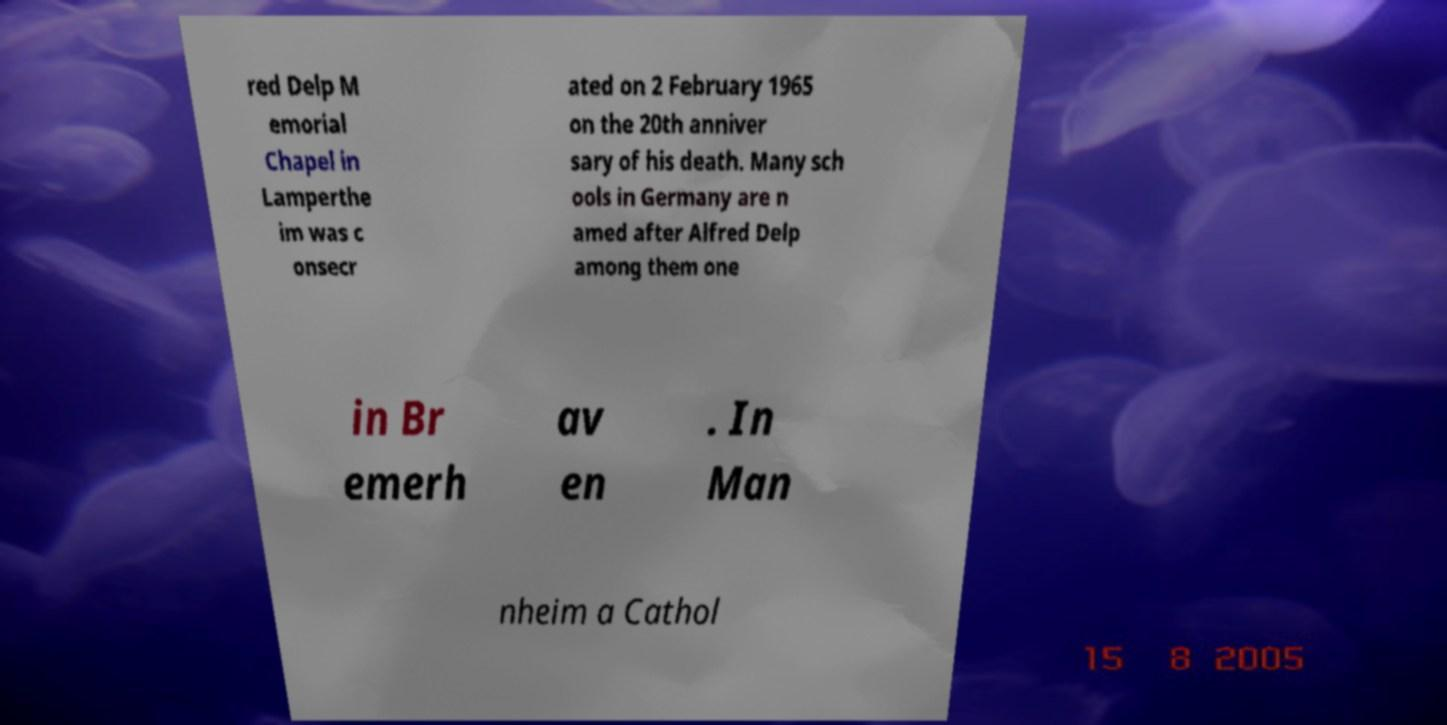I need the written content from this picture converted into text. Can you do that? red Delp M emorial Chapel in Lamperthe im was c onsecr ated on 2 February 1965 on the 20th anniver sary of his death. Many sch ools in Germany are n amed after Alfred Delp among them one in Br emerh av en . In Man nheim a Cathol 